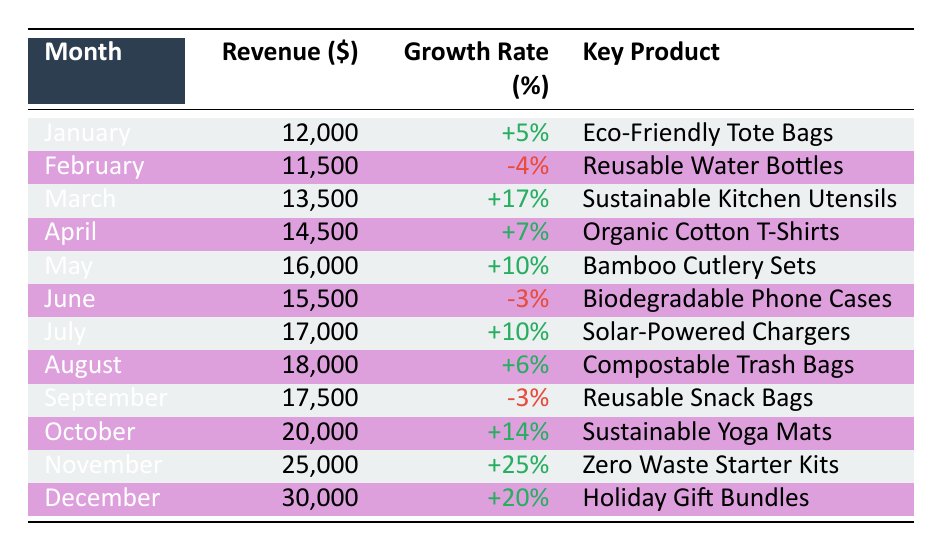What was the highest monthly revenue in 2023? The table indicates that the highest revenue was recorded in December at 30,000.
Answer: 30,000 What was the key product with the highest growth rate? November had the highest growth rate of 25%, with the key product being Zero Waste Starter Kits.
Answer: Zero Waste Starter Kits In which month was revenue lower than January? In February, the revenue was 11,500, which is lower than January's revenue of 12,000.
Answer: February What was the average revenue from January to May? The revenue from January to May is 12,000, 11,500, 13,500, 14,500, and 16,000. The total for these months is 67,500. Dividing by 5 gives an average of 13,500.
Answer: 13,500 Was there a revenue increase every month? No, February and June show a decline in revenue, specifically -4% and -3% respectively.
Answer: No What was the revenue in April and how does it compare to June? April's revenue was 14,500 and June's was 15,500, showing that June had higher revenue by 1,000.
Answer: April had 14,500, June had 15,500 What was the total revenue for the second half of the year? The total revenue for the second half consists of July (17,000), August (18,000), September (17,500), October (20,000), November (25,000), December (30,000). Summing these gives 127,500.
Answer: 127,500 How many months had a positive growth rate greater than 10%? In the data, March, May, July, October, November, and December experienced positive growth rates greater than 10%. That’s a total of 6 months.
Answer: 6 months What was the key product sold in June? The key product in June was Biodegradable Phone Cases.
Answer: Biodegradable Phone Cases 